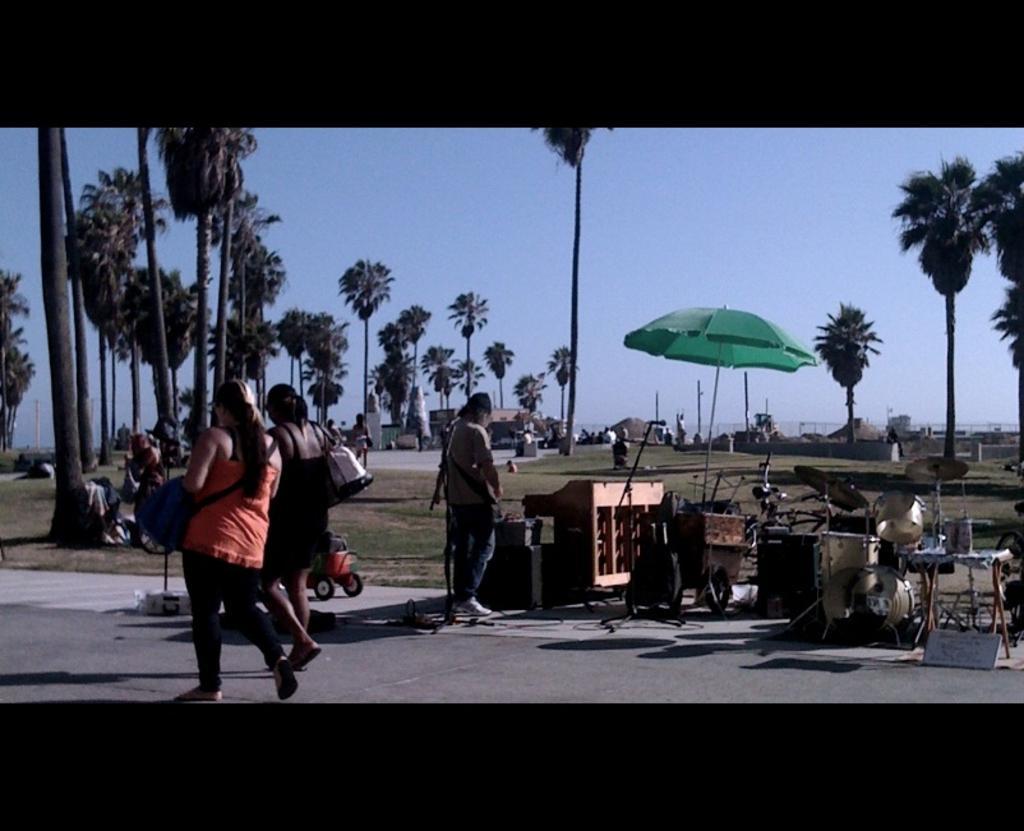Describe this image in one or two sentences. In this image, we can see few people. Few are walking on the road. Right side of the image, we can see musical instruments, stands with mics. Here we can see some vehicle. Background there are so many trees, umbrella, huts. Top of the image, there is a sky. 